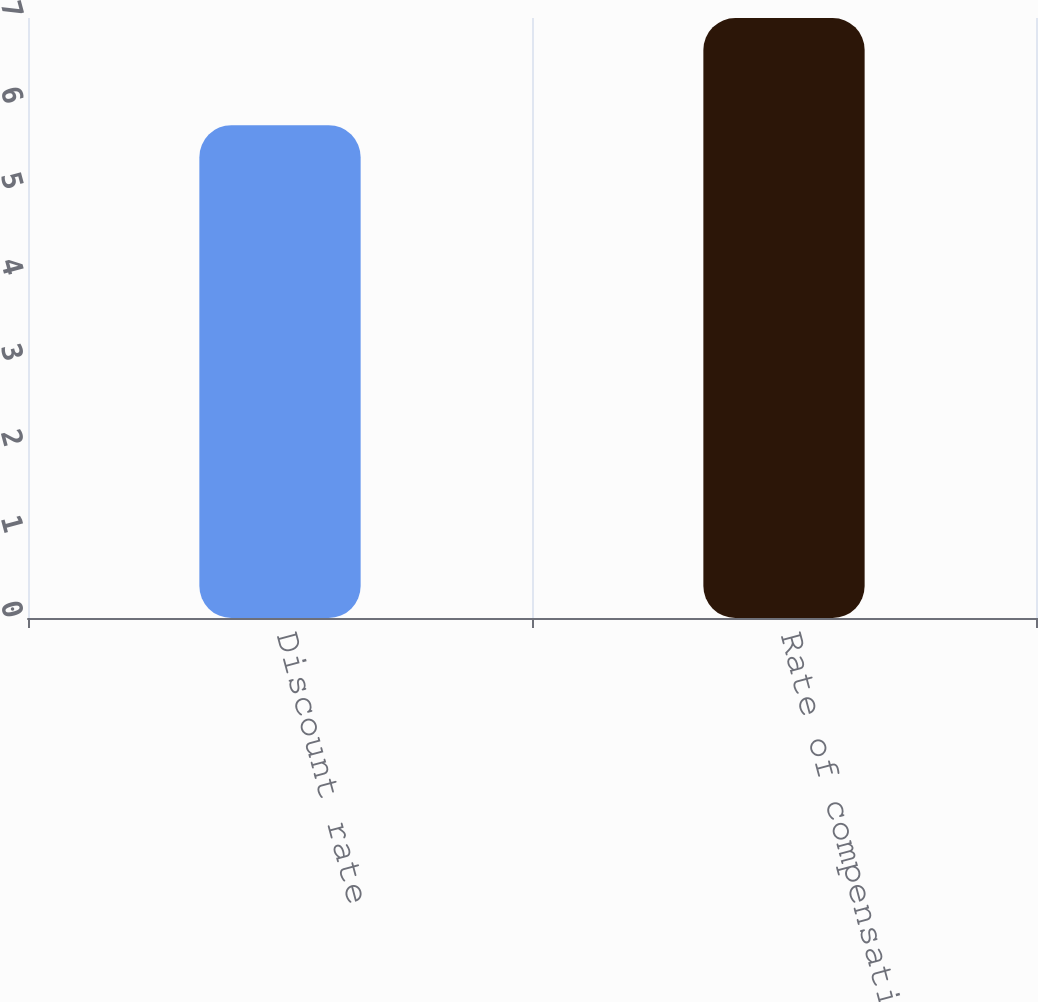<chart> <loc_0><loc_0><loc_500><loc_500><bar_chart><fcel>Discount rate<fcel>Rate of compensation increase<nl><fcel>5.75<fcel>7<nl></chart> 